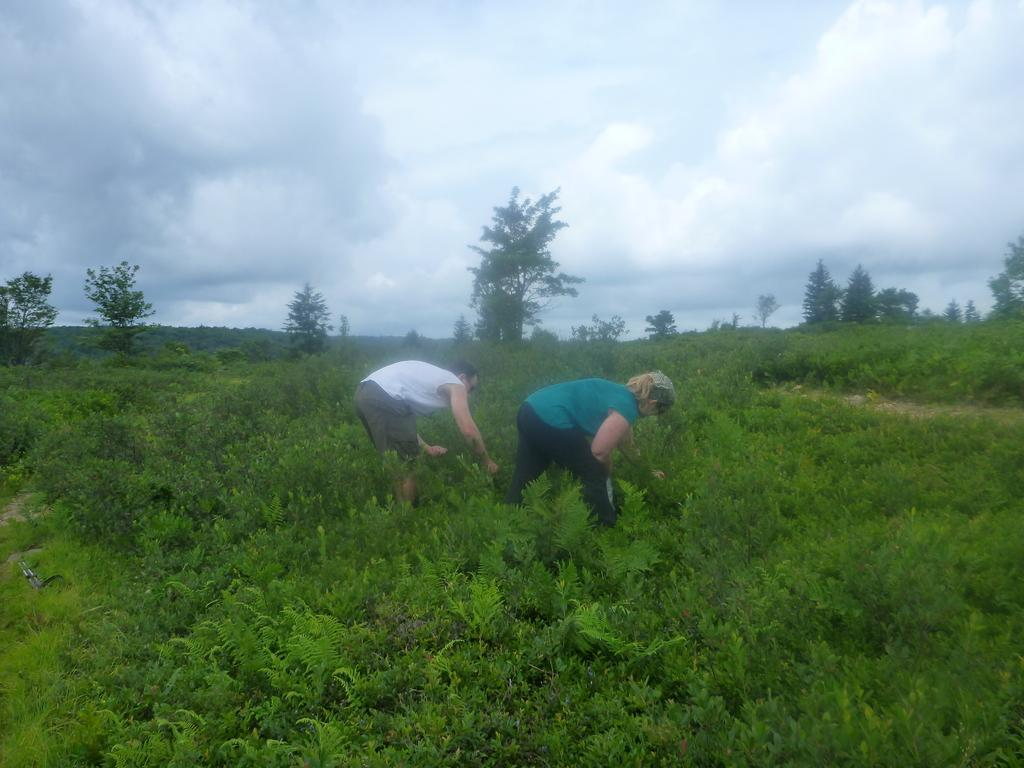What type of living organisms can be seen in the image? Plants and trees are visible in the image. How many people are present in the image? There are two people in the image. What is visible at the top of the image? The sky is visible at the top of the image. What type of interest does the fireman have in the steel structure in the image? There is no fireman or steel structure present in the image. What type of steel is used to construct the plants in the image? The plants in the image are living organisms and do not require steel for construction. 